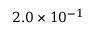Convert formula to latex. <formula><loc_0><loc_0><loc_500><loc_500>2 . 0 \times 1 0 ^ { - 1 }</formula> 